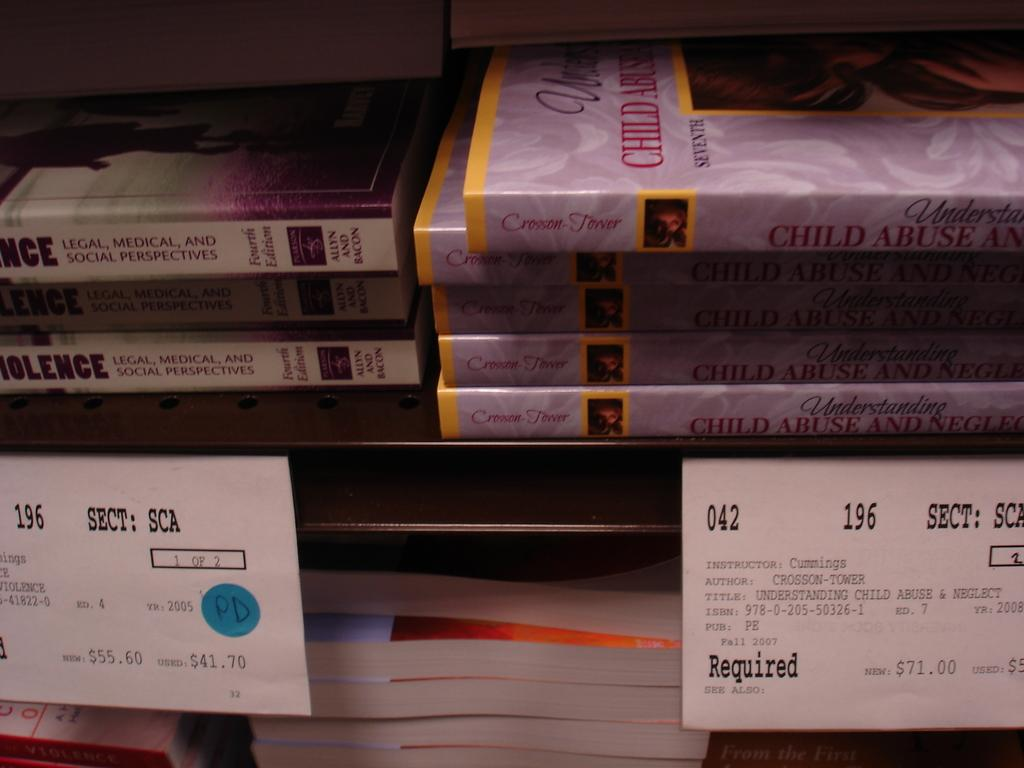Provide a one-sentence caption for the provided image. A shelve at a school bookstore depicting the price, section, author, and class Instructor name for each book. 